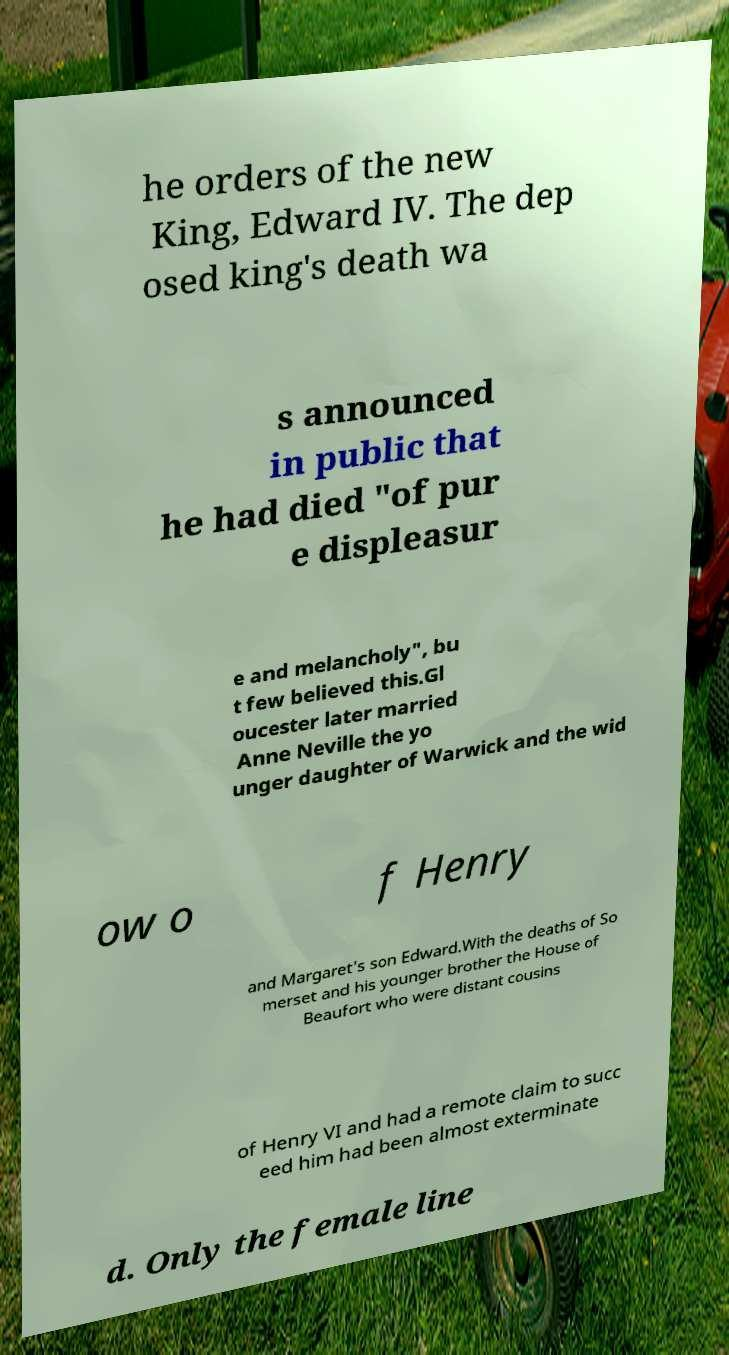Please identify and transcribe the text found in this image. he orders of the new King, Edward IV. The dep osed king's death wa s announced in public that he had died "of pur e displeasur e and melancholy", bu t few believed this.Gl oucester later married Anne Neville the yo unger daughter of Warwick and the wid ow o f Henry and Margaret's son Edward.With the deaths of So merset and his younger brother the House of Beaufort who were distant cousins of Henry VI and had a remote claim to succ eed him had been almost exterminate d. Only the female line 